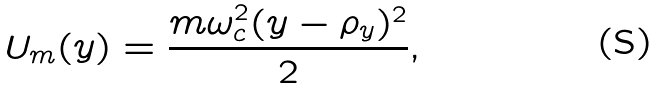<formula> <loc_0><loc_0><loc_500><loc_500>U _ { m } ( y ) = \frac { m \omega _ { c } ^ { 2 } ( y - \rho _ { y } ) ^ { 2 } } { 2 } ,</formula> 